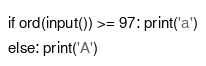<code> <loc_0><loc_0><loc_500><loc_500><_Python_>if ord(input()) >= 97: print('a')
else: print('A')</code> 